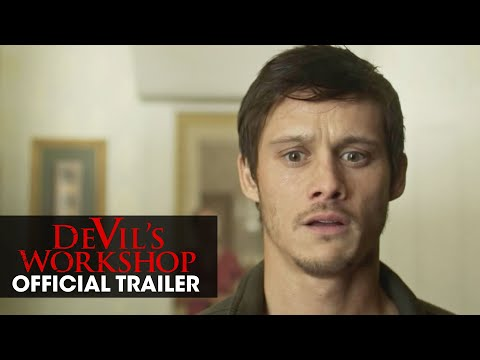Explain what emotions this image evokes and how it achieves it. The image evokes a strong sense of shock and vulnerability which is achieved through the actor's wide eyes and open mouth. The plain background ensures that there are no distractions from his facial expressions, accentuating the emotional intensity. What could the single painting in the background suggest about the scene? The single painting in the background could symbolize isolation or singularity, reflecting the character's possible feeling of being alone or central to the plot's conflict. It adds a subtle layer of depth, perhaps hinting at the character's internal or external struggles. 